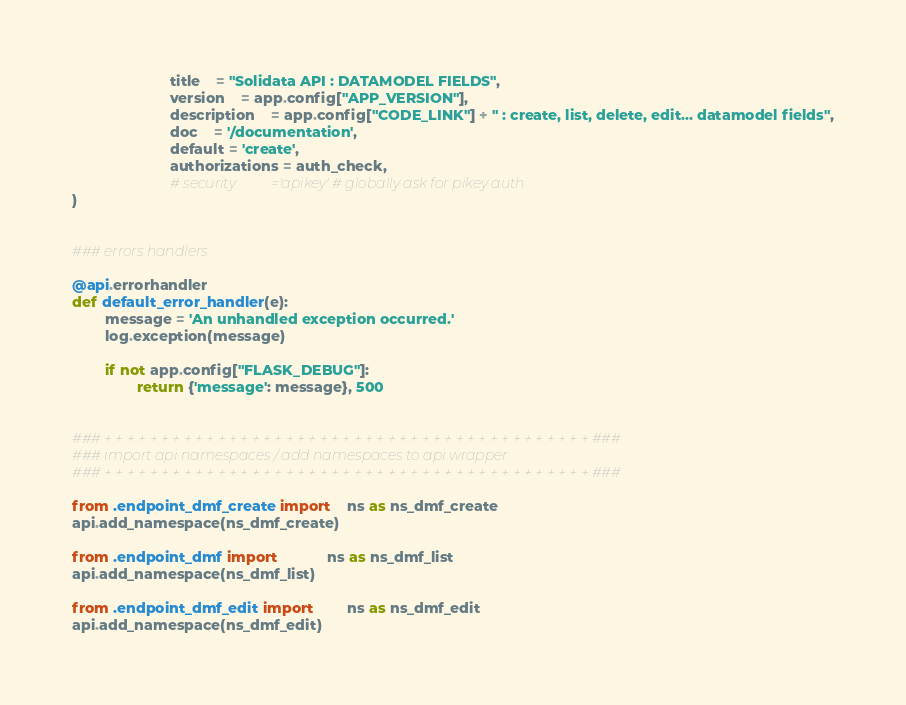<code> <loc_0><loc_0><loc_500><loc_500><_Python_>						title	= "Solidata API : DATAMODEL FIELDS",
						version	= app.config["APP_VERSION"],
						description	= app.config["CODE_LINK"] + " : create, list, delete, edit... datamodel fields",
						doc	= '/documentation',
						default = 'create',
						authorizations = auth_check,
						# security			='apikey' # globally ask for pikey auth
)


### errors handlers

@api.errorhandler
def default_error_handler(e):
		message = 'An unhandled exception occurred.'
		log.exception(message)

		if not app.config["FLASK_DEBUG"]:
				return {'message': message}, 500


### + + + + + + + + + + + + + + + + + + + + + + + + + + + + + + + + + + + + + + + + + + + ###
### import api namespaces / add namespaces to api wrapper
### + + + + + + + + + + + + + + + + + + + + + + + + + + + + + + + + + + + + + + + + + + + ###

from .endpoint_dmf_create import 	ns as ns_dmf_create
api.add_namespace(ns_dmf_create)

from .endpoint_dmf import 			ns as ns_dmf_list
api.add_namespace(ns_dmf_list)

from .endpoint_dmf_edit import 		ns as ns_dmf_edit
api.add_namespace(ns_dmf_edit)
</code> 